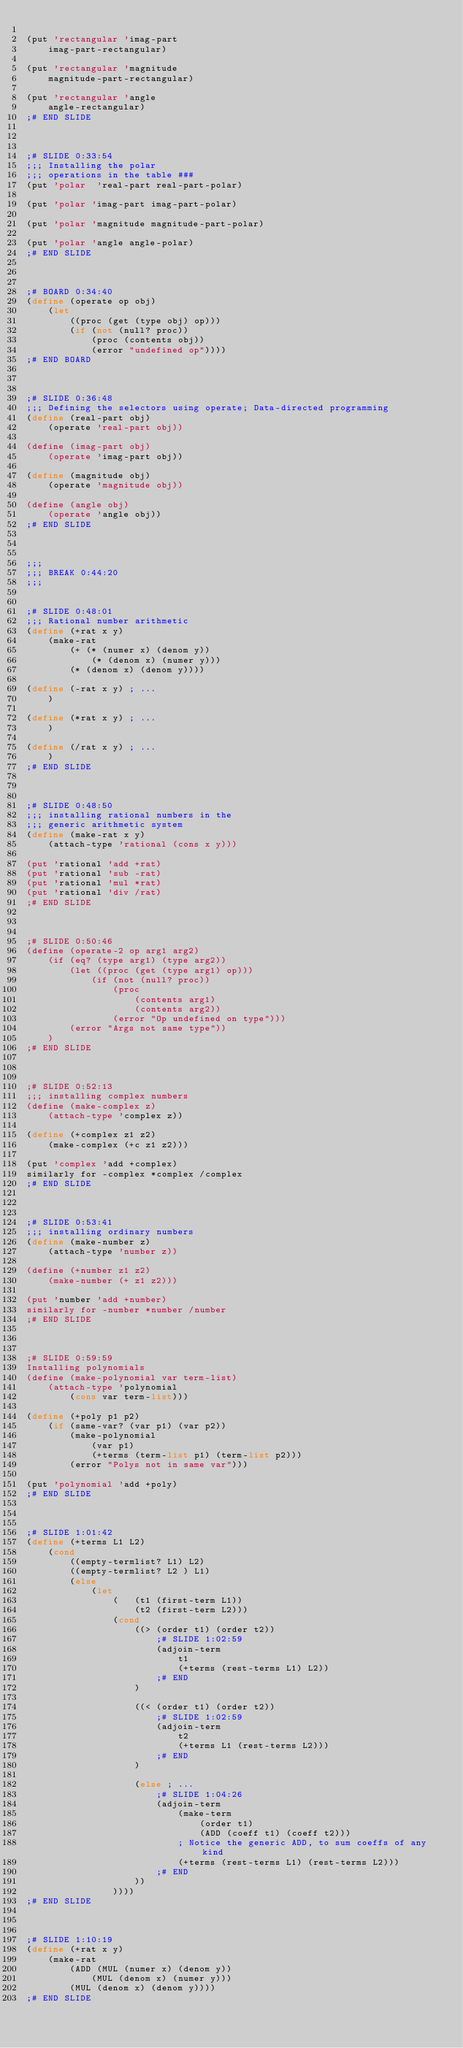<code> <loc_0><loc_0><loc_500><loc_500><_Scheme_>
(put 'rectangular 'imag-part
	imag-part-rectangular)

(put 'rectangular 'magnitude
	magnitude-part-rectangular)

(put 'rectangular 'angle
	angle-rectangular)
;# END SLIDE



;# SLIDE 0:33:54
;;; Installing the polar
;;; operations in the table ###
(put 'polar  'real-part real-part-polar)

(put 'polar 'imag-part imag-part-polar)

(put 'polar 'magnitude magnitude-part-polar)

(put 'polar 'angle angle-polar)
;# END SLIDE



;# BOARD 0:34:40
(define (operate op obj)
	(let
		((proc (get (type obj) op)))
		(if (not (null? proc))
			(proc (contents obj))
			(error "undefined op"))))
;# END BOARD



;# SLIDE 0:36:48
;;; Defining the selectors using operate; Data-directed programming 
(define (real-part obj)
	(operate 'real-part obj))

(define (imag-part obj)
	(operate 'imag-part obj))

(define (magnitude obj)
	(operate 'magnitude obj))

(define (angle obj)
	(operate 'angle obj))
;# END SLIDE



;;;
;;; BREAK 0:44:20
;;;


;# SLIDE 0:48:01
;;; Rational number arithmetic
(define (+rat x y)
	(make-rat
		(+ (* (numer x) (denom y))
			(* (denom x) (numer y)))
		(* (denom x) (denom y))))

(define (-rat x y) ; ...
	)

(define (*rat x y) ; ...
	)

(define (/rat x y) ; ...
	)
;# END SLIDE



;# SLIDE 0:48:50
;;; installing rational numbers in the
;;; generic arithmetic system
(define (make-rat x y)
	(attach-type 'rational (cons x y)))

(put 'rational 'add +rat)
(put 'rational 'sub -rat)
(put 'rational 'mul *rat)
(put 'rational 'div /rat)
;# END SLIDE



;# SLIDE 0:50:46
(define (operate-2 op arg1 arg2)
	(if (eq? (type arg1) (type arg2))
		(let ((proc (get (type arg1) op)))
			(if (not (null? proc))
				(proc
					(contents arg1)
					(contents arg2))
				(error "Op undefined on type")))
		(error "Args not same type"))
	)
;# END SLIDE



;# SLIDE 0:52:13
;;; installing complex numbers
(define (make-complex z)
	(attach-type 'complex z))

(define (+complex z1 z2)
	(make-complex (+c z1 z2)))

(put 'complex 'add +complex)
similarly for -complex *complex /complex
;# END SLIDE



;# SLIDE 0:53:41
;;; installing ordinary numbers
(define (make-number z)
	(attach-type 'number z))

(define (+number z1 z2)
	(make-number (+ z1 z2)))

(put 'number 'add +number)
similarly for -number *number /number
;# END SLIDE



;# SLIDE 0:59:59
Installing polynomials
(define (make-polynomial var term-list)
	(attach-type 'polynomial
		(cons var term-list)))

(define (+poly p1 p2)
	(if (same-var? (var p1) (var p2))
		(make-polynomial
			(var p1)
			(+terms (term-list p1) (term-list p2)))
		(error "Polys not in same var")))

(put 'polynomial 'add +poly)
;# END SLIDE



;# SLIDE 1:01:42
(define (+terms L1 L2)
	(cond
		((empty-termlist? L1) L2)
		((empty-termlist? L2 ) L1)
		(else
			(let
				(	(t1 (first-term L1))
					(t2 (first-term L2)))
				(cond
					((> (order t1) (order t2))
						;# SLIDE 1:02:59
						(adjoin-term
							t1
							(+terms (rest-terms L1) L2))
						;# END
					)

					((< (order t1) (order t2))
						;# SLIDE 1:02:59
						(adjoin-term 
							t2
							(+terms L1 (rest-terms L2)))
						;# END
					)

					(else ; ...
						;# SLIDE 1:04:26
						(adjoin-term
							(make-term
								(order t1)
								(ADD (coeff t1) (coeff t2)))
							; Notice the generic ADD, to sum coeffs of any kind
							(+terms (rest-terms L1) (rest-terms L2)))
						;# END
					))
				))))
;# END SLIDE



;# SLIDE 1:10:19
(define (+rat x y)
	(make-rat
		(ADD (MUL (numer x) (denom y))
			(MUL (denom x) (numer y)))
		(MUL (denom x) (denom y))))
;# END SLIDE


</code> 